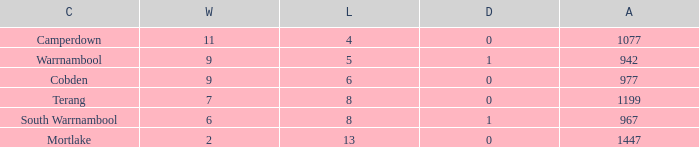How many wins did Cobden have when draws were more than 0? 0.0. 